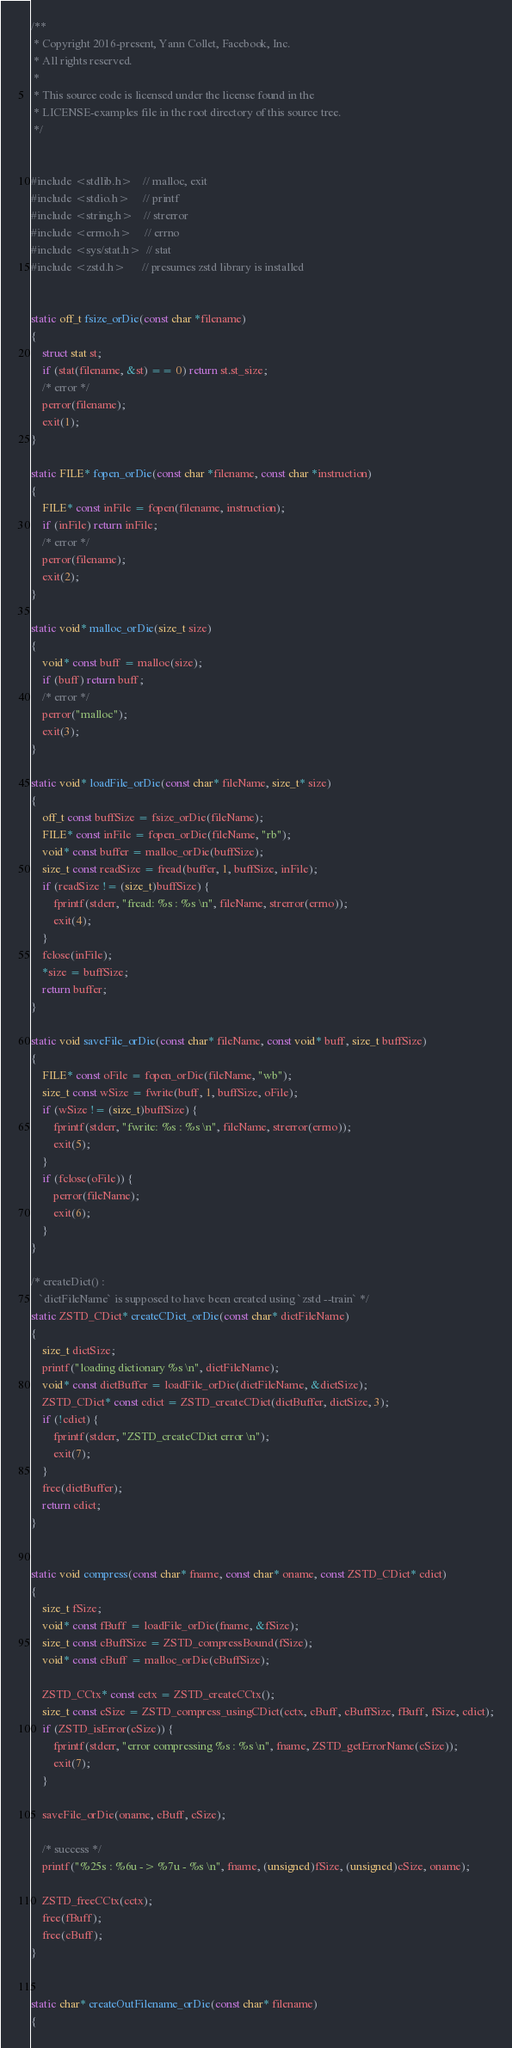<code> <loc_0><loc_0><loc_500><loc_500><_C_>/**
 * Copyright 2016-present, Yann Collet, Facebook, Inc.
 * All rights reserved.
 *
 * This source code is licensed under the license found in the
 * LICENSE-examples file in the root directory of this source tree.
 */


#include <stdlib.h>    // malloc, exit
#include <stdio.h>     // printf
#include <string.h>    // strerror
#include <errno.h>     // errno
#include <sys/stat.h>  // stat
#include <zstd.h>      // presumes zstd library is installed


static off_t fsize_orDie(const char *filename)
{
    struct stat st;
    if (stat(filename, &st) == 0) return st.st_size;
    /* error */
    perror(filename);
    exit(1);
}

static FILE* fopen_orDie(const char *filename, const char *instruction)
{
    FILE* const inFile = fopen(filename, instruction);
    if (inFile) return inFile;
    /* error */
    perror(filename);
    exit(2);
}

static void* malloc_orDie(size_t size)
{
    void* const buff = malloc(size);
    if (buff) return buff;
    /* error */
    perror("malloc");
    exit(3);
}

static void* loadFile_orDie(const char* fileName, size_t* size)
{
    off_t const buffSize = fsize_orDie(fileName);
    FILE* const inFile = fopen_orDie(fileName, "rb");
    void* const buffer = malloc_orDie(buffSize);
    size_t const readSize = fread(buffer, 1, buffSize, inFile);
    if (readSize != (size_t)buffSize) {
        fprintf(stderr, "fread: %s : %s \n", fileName, strerror(errno));
        exit(4);
    }
    fclose(inFile);
    *size = buffSize;
    return buffer;
}

static void saveFile_orDie(const char* fileName, const void* buff, size_t buffSize)
{
    FILE* const oFile = fopen_orDie(fileName, "wb");
    size_t const wSize = fwrite(buff, 1, buffSize, oFile);
    if (wSize != (size_t)buffSize) {
        fprintf(stderr, "fwrite: %s : %s \n", fileName, strerror(errno));
        exit(5);
    }
    if (fclose(oFile)) {
        perror(fileName);
        exit(6);
    }
}

/* createDict() :
   `dictFileName` is supposed to have been created using `zstd --train` */
static ZSTD_CDict* createCDict_orDie(const char* dictFileName)
{
    size_t dictSize;
    printf("loading dictionary %s \n", dictFileName);
    void* const dictBuffer = loadFile_orDie(dictFileName, &dictSize);
    ZSTD_CDict* const cdict = ZSTD_createCDict(dictBuffer, dictSize, 3);
    if (!cdict) {
        fprintf(stderr, "ZSTD_createCDict error \n");
        exit(7);
    }
    free(dictBuffer);
    return cdict;
}


static void compress(const char* fname, const char* oname, const ZSTD_CDict* cdict)
{
    size_t fSize;
    void* const fBuff = loadFile_orDie(fname, &fSize);
    size_t const cBuffSize = ZSTD_compressBound(fSize);
    void* const cBuff = malloc_orDie(cBuffSize);

    ZSTD_CCtx* const cctx = ZSTD_createCCtx();
    size_t const cSize = ZSTD_compress_usingCDict(cctx, cBuff, cBuffSize, fBuff, fSize, cdict);
    if (ZSTD_isError(cSize)) {
        fprintf(stderr, "error compressing %s : %s \n", fname, ZSTD_getErrorName(cSize));
        exit(7);
    }

    saveFile_orDie(oname, cBuff, cSize);

    /* success */
    printf("%25s : %6u -> %7u - %s \n", fname, (unsigned)fSize, (unsigned)cSize, oname);

    ZSTD_freeCCtx(cctx);
    free(fBuff);
    free(cBuff);
}


static char* createOutFilename_orDie(const char* filename)
{</code> 